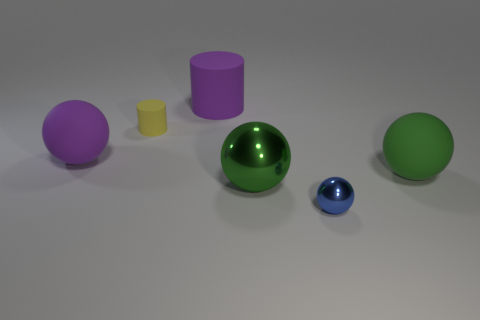Are there fewer green spheres on the left side of the blue metallic sphere than brown metallic cubes?
Ensure brevity in your answer.  No. The matte thing that is the same size as the blue metal thing is what shape?
Give a very brief answer. Cylinder. How many other things are there of the same color as the tiny matte cylinder?
Your response must be concise. 0. Is the purple ball the same size as the yellow thing?
Give a very brief answer. No. How many objects are either green metal things or matte things that are in front of the large cylinder?
Offer a terse response. 4. Are there fewer small shiny objects to the left of the tiny shiny object than tiny yellow objects that are in front of the large green rubber ball?
Offer a terse response. No. How many other things are there of the same material as the tiny ball?
Give a very brief answer. 1. Does the matte sphere to the right of the big rubber cylinder have the same color as the small shiny thing?
Your answer should be compact. No. Is there a big matte cylinder to the left of the matte cylinder on the left side of the big rubber cylinder?
Your response must be concise. No. There is a big object that is on the right side of the large matte cylinder and on the left side of the small blue thing; what material is it?
Ensure brevity in your answer.  Metal. 